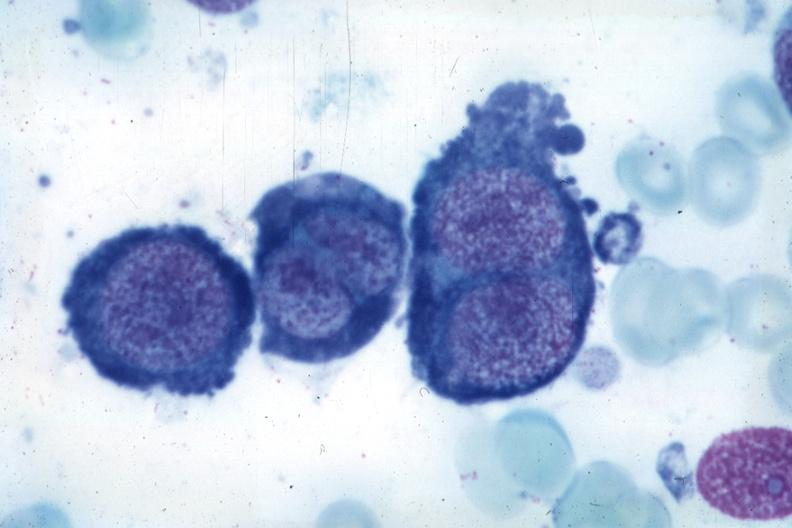s cachexia present?
Answer the question using a single word or phrase. No 